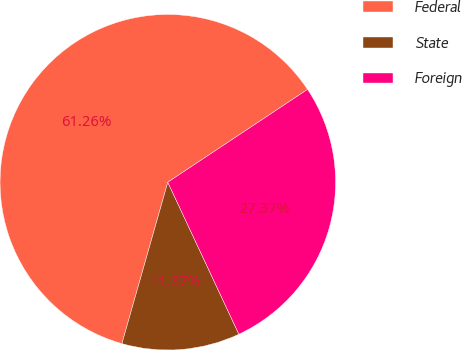Convert chart to OTSL. <chart><loc_0><loc_0><loc_500><loc_500><pie_chart><fcel>Federal<fcel>State<fcel>Foreign<nl><fcel>61.26%<fcel>11.37%<fcel>27.37%<nl></chart> 